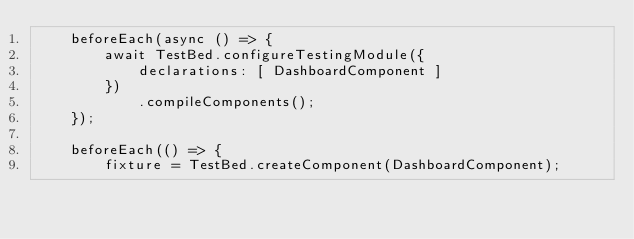<code> <loc_0><loc_0><loc_500><loc_500><_TypeScript_>    beforeEach(async () => {
        await TestBed.configureTestingModule({
            declarations: [ DashboardComponent ]
        })
            .compileComponents();
    });

    beforeEach(() => {
        fixture = TestBed.createComponent(DashboardComponent);</code> 